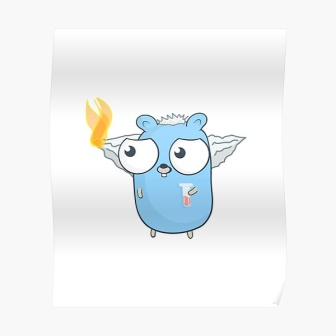If this creature could speak, what do you think it would sound like? I imagine the creature having a soft, melodious voice that carries a comforting and enchanting tone. Its voice would resemble the gentle rustle of leaves or the soothing flow of a stream, evoking a sense of peace and wonder. When it speaks, it would do so with a playful lilt, infusing each word with warmth and curiosity. Its laughter would be like the tinkling of chimes, resonating joyfully through the air and bringing smiles to those who hear it. What kind of adventures might this creature go on? The creature would likely embark on a variety of enchanting adventures, each more magical than the last. It might journey to hidden realms within its forest, discovering ancient ruins and unlocking forgotten secrets. Along the way, it would form bonds with other mystical inhabitants, each with their own unique powers and stories. Perhaps it would navigate through enchanted groves where time flows differently or dance with the spirits of the forest under a moonlit sky. Another adventure might see it venturing beyond its homeland to distant, dreamlike lands, solving mysteries and spreading the light of its flame to bring hope and happiness wherever it goes. Can you describe a scenario where the creature is in danger? Sure. Imagine our whimsical creature deep within the heart of the forest, where it accidentally stumbles upon an ancient, forbidden grove guarded by spirits who distrust outsiders. The once serene atmosphere changes abruptly as shadows lengthen and the air grows thick with tension. The guardians of the grove, looming and spectral, surround the creature menacingly. However, instead of fleeing, the creature’s flame burns with a fierce, bright determination. It uses its gentle, melodious voice to communicate its intentions, dispelling the spirits' mistrust and slowly letting the grove's vitality return. The scene is a mix of tension and beauty, displaying the creature’s bravery and the power of communication. Why does this creature have wings? The wings on this creature likely symbolize its freedom and ability to transcend the ordinary. They suggest that the creature can move effortlessly between realms or places, visiting dreamy landscapes and magical realms beyond the forest. The wings might also indicate an intrinsic connection to the ethereal forces of nature, granting it the ability to soar through the sky, delivering messages of peace and hope. Alternatively, the wings could be remnants of an ancient lineage, with tales of how these creatures were once celestial beings who watched over the world, now living humbly and playfully among the forest’s inhabitants. Imagine a festive celebration in the creature's forest. In the heart of the magical forest, under the canopy of towering trees adorned with glowing lanterns, creatures of all shapes and sizes gather for a grand festive celebration. The air is filled with laughter and the melodious sounds of forest instruments crafted from nature's bounty. Our whimsical blue creature, with its radiant flame and fluttering wings, dances joyfully with friends, creating arcs of light in the night sky. Brightly colored flowers bloom spontaneously around the gathering, adding splashes of vibrant hues to the scene. The celebration includes feasts of enchanted fruits, storytelling sessions by the ancient tree spirits, and dance performances that recount the legends of the forest. The night culminates in a dazzling display of bioluminescent fireflies, orchestrated by the creature, painting the sky with their enchanting glow, leaving everyone in awe of the forest’s timeless magic. 